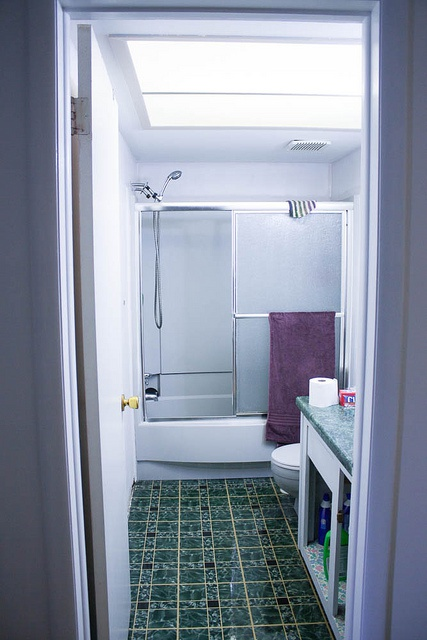Describe the objects in this image and their specific colors. I can see toilet in black, lavender, gray, and blue tones, bottle in black, navy, and gray tones, and bottle in black, darkgreen, purple, and darkblue tones in this image. 